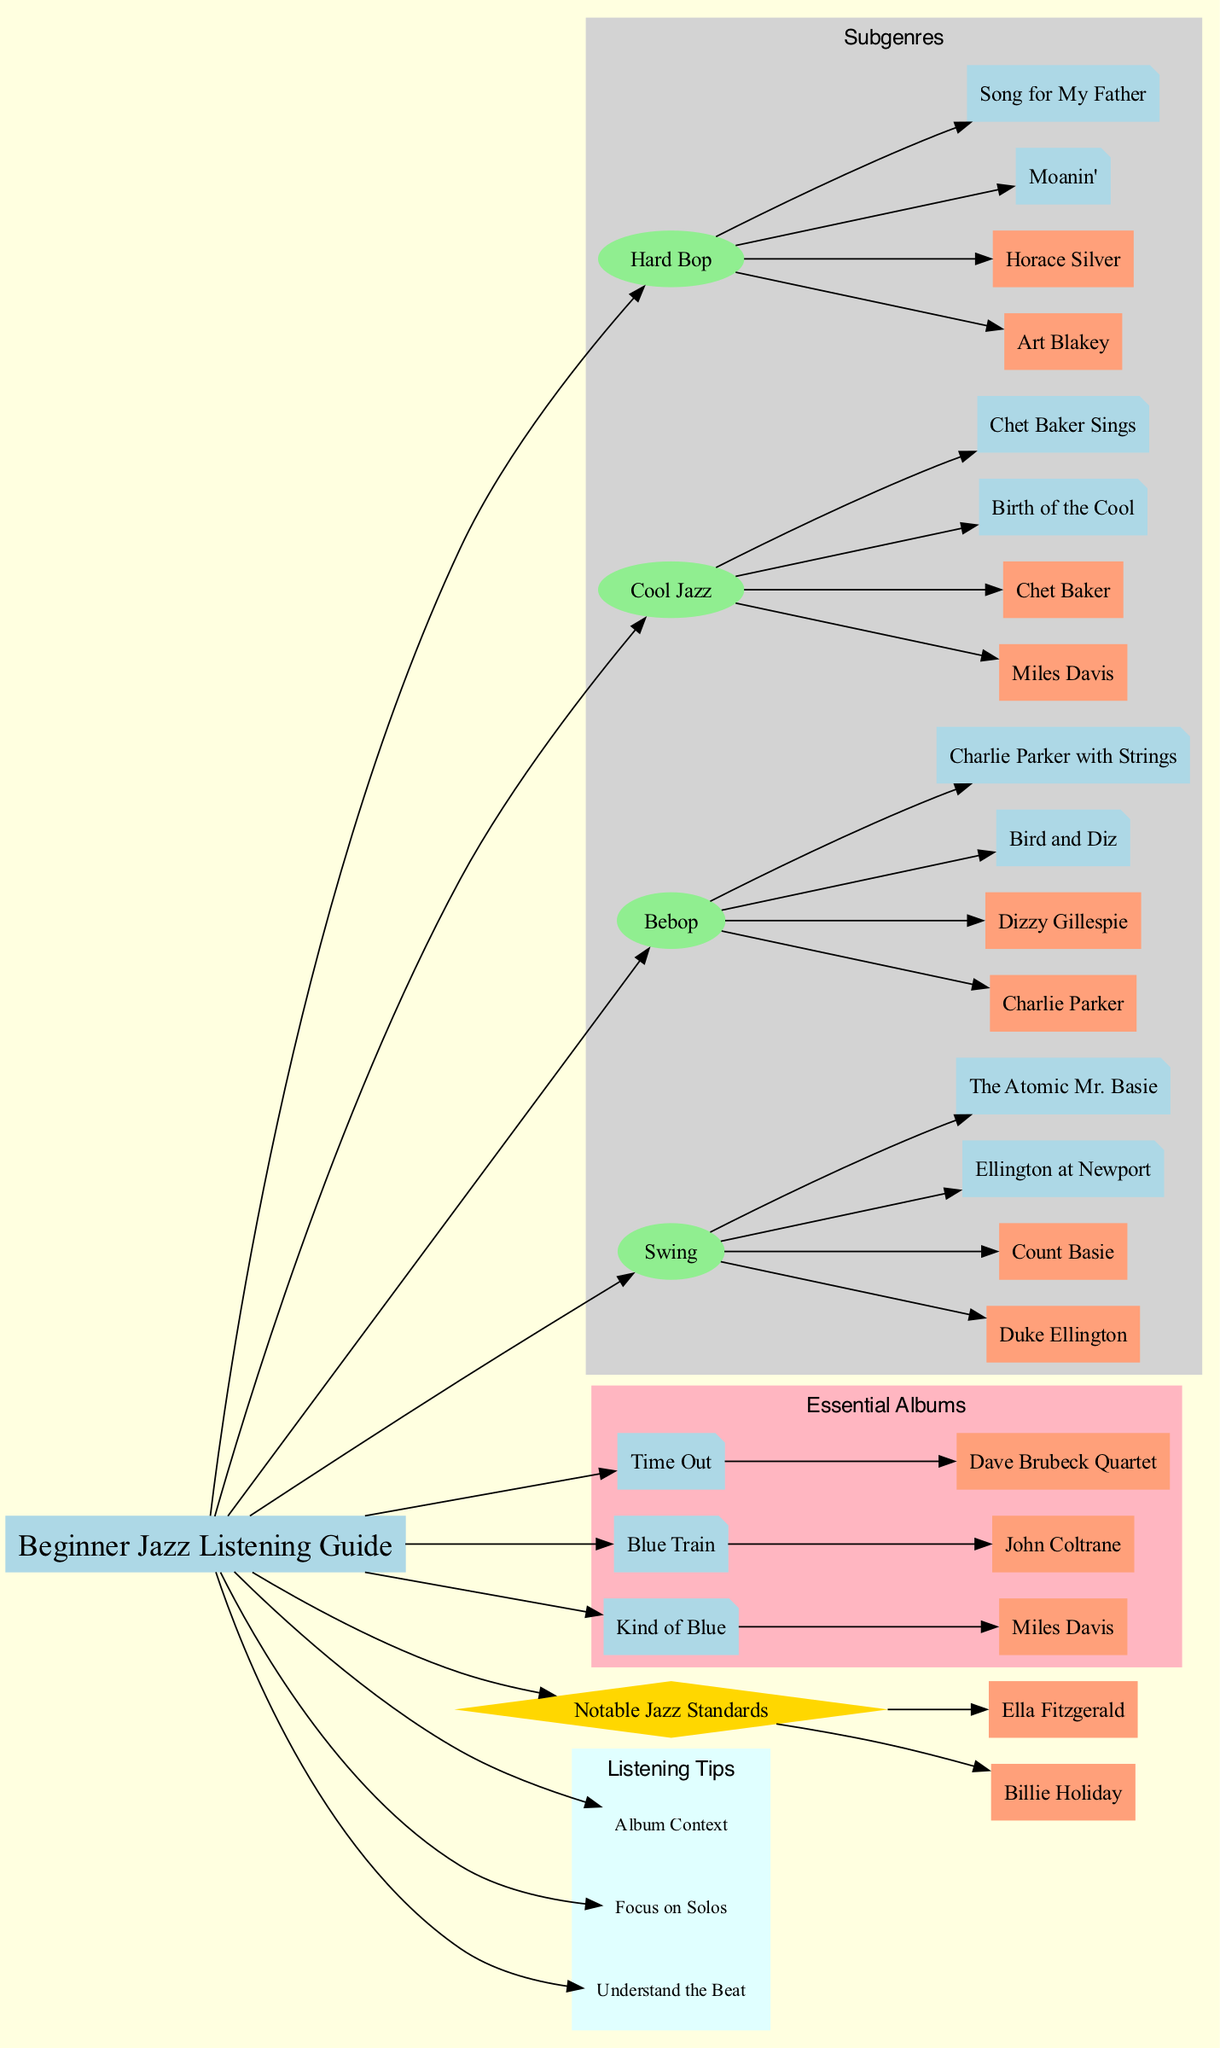What are the two subgenres of jazz listed in the diagram? The diagram identifies four subgenres organized under the "Subgenres" cluster. They are Swing and Bebop, among others. By checking the list of subgenres, you can find both terms.
Answer: Swing and Bebop Who is the artist associated with the album "Kind of Blue"? Within the "Essential Albums" section, the album "Kind of Blue" is linked to the artist Miles Davis, as shown in the diagram. This connection is typically represented with an edge connecting the album to the artist node.
Answer: Miles Davis How many artists are listed under the "Notable Jazz Standards"? The diagram includes two artists listed in the "Notable Jazz Standards" section, namely Ella Fitzgerald and Billie Holiday. Counting the artist nodes in that cluster reveals the total.
Answer: 2 Which recommended track is associated with the artist Dizzy Gillespie? In the "Bebop" subgenre, the track "A Night in Tunisia" is connected to the artist Dizzy Gillespie. You can find this by looking at the edges connecting artist nodes to their respective recommended tracks.
Answer: A Night in Tunisia How many recommended albums are there under the "Cool Jazz" subgenre? The "Cool Jazz" subgenre within the diagram lists two recommended albums: "Birth of the Cool" and "Chet Baker Sings." By counting the album nodes in that specific subgenre cluster, you can derive this number.
Answer: 2 Which listening tip suggests paying attention to the rhythm section? The diagram's "Listening Tips" section includes the tip "Understand the Beat," which emphasizes focusing on the rhythm section when listening to jazz. This connection can be traced through the node representing that specific tip.
Answer: Understand the Beat Which two essential albums are connected to the artist John Coltrane? The diagram lists one essential album under John Coltrane, specifically "Blue Train." Since there is only one album associated with that artist, no second album is mentioned in this context. You find this by reviewing the connections under the "Essential Albums" part.
Answer: Blue Train What is the color used to denote the "Subgenres" section in the diagram? The "Subgenres" section is represented in the diagram using a light grey color. This can be confirmed by examining the attributes assigned to the subgraph that contains these nodes.
Answer: light grey 